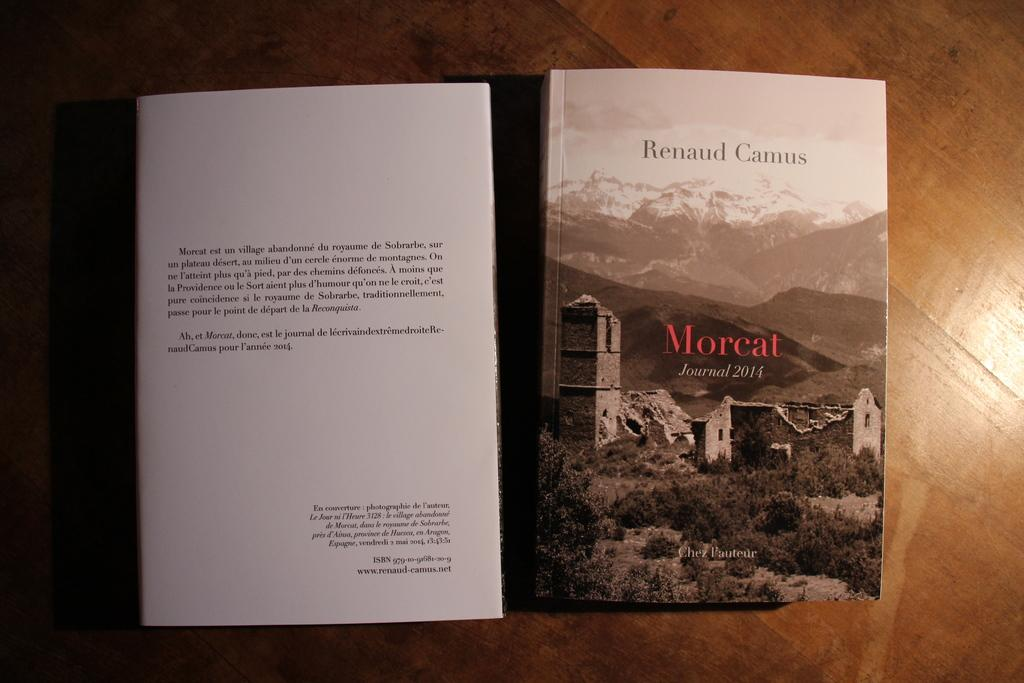<image>
Provide a brief description of the given image. A book titled Morcat by Renaud Camus has a stone building in ruins on the cover. 